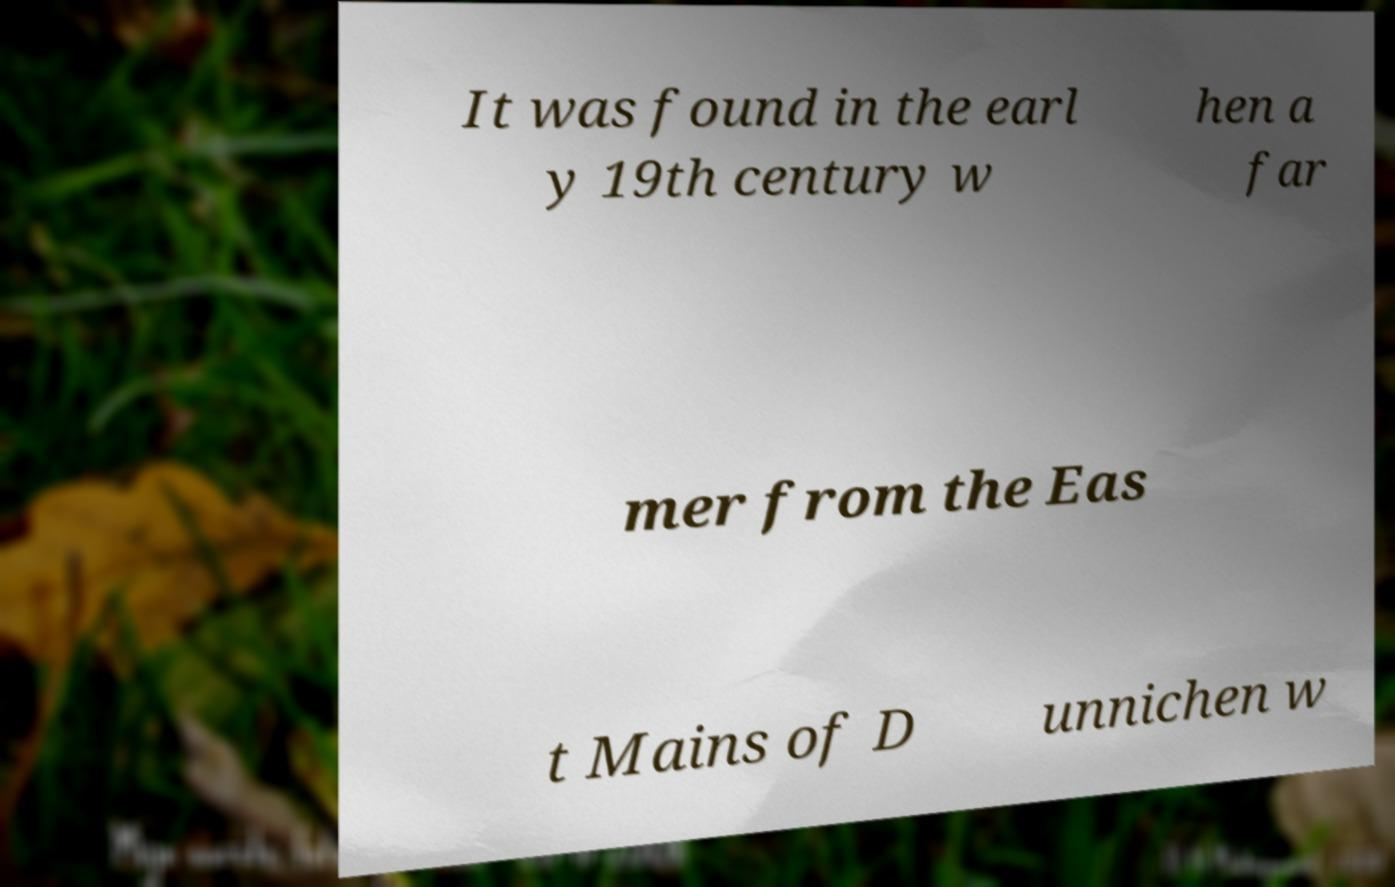Can you read and provide the text displayed in the image?This photo seems to have some interesting text. Can you extract and type it out for me? It was found in the earl y 19th century w hen a far mer from the Eas t Mains of D unnichen w 